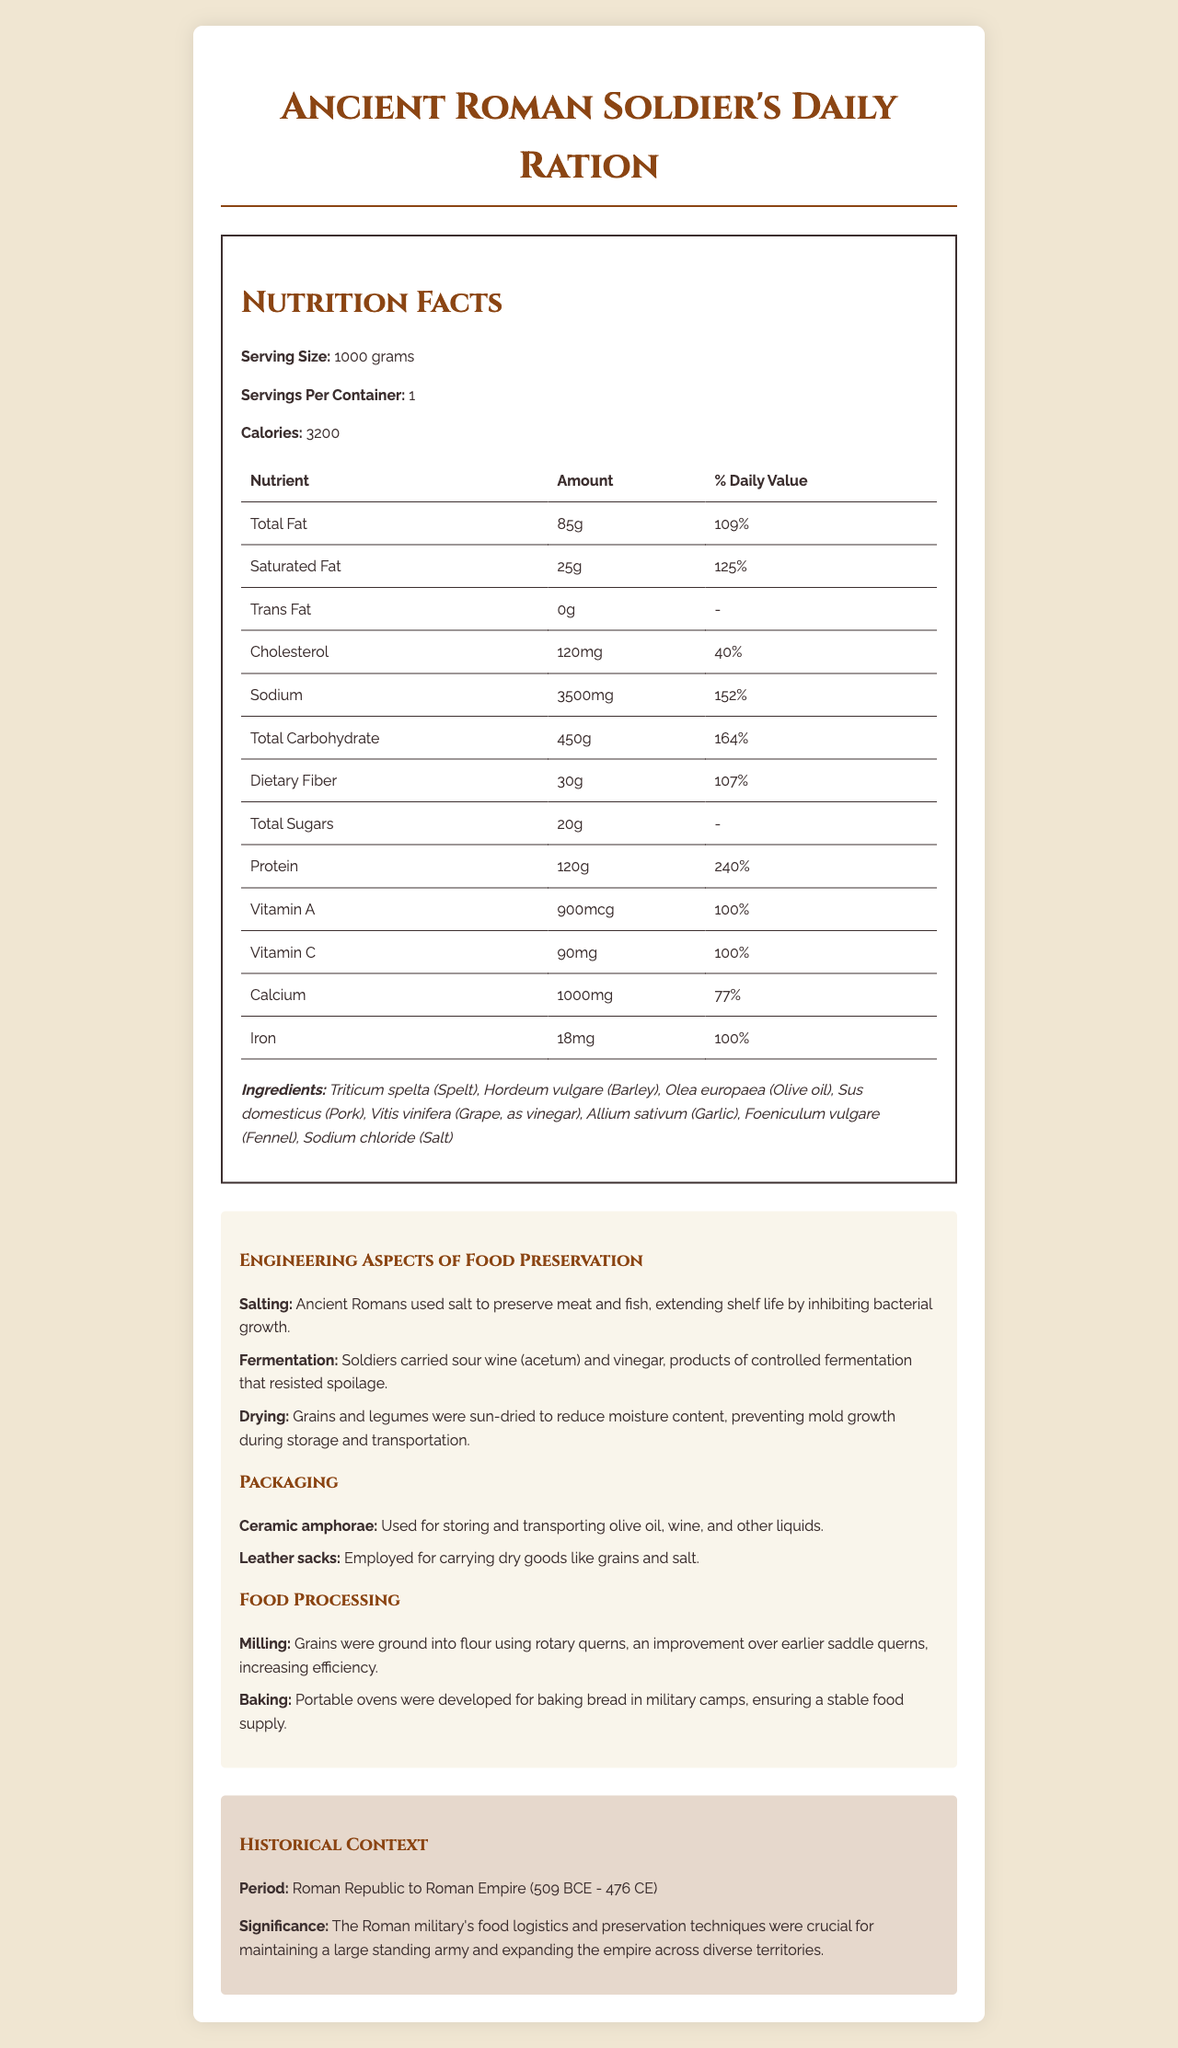what is the calorie count for a serving? The document specifies that the calorie count per serving is 3200 calories.
Answer: 3200 calories what are the main ingredients listed for the Ancient Roman Soldier's Daily Ration? The document lists these as the main ingredients under the ingredients section.
Answer: Triticum spelta (Spelt), Hordeum vulgare (Barley), Olea europaea (Olive oil), Sus domesticus (Pork), Vitis vinifera (Grape, as vinegar), Allium sativum (Garlic), Foeniculum vulgare (Fennel), Sodium chloride (Salt) how does milling improve food processing? The document mentions that milling grains into flour using rotary querns improves efficiency.
Answer: It increases efficiency by grinding grains into flour using rotary querns, which are an improvement over earlier saddle querns. what method was used by the Romans to preserve their meat and fish? The document states that salt was used by the Romans to preserve meat and fish.
Answer: Salting what is the historical significance of the food logistics and preservation techniques used by the Roman military? The document explains that these techniques were significant for maintaining the Roman military's strength and expansion.
Answer: They were crucial for maintaining a large standing army and expanding the empire across diverse territories. how much total fat is in one serving of the ration? The document states that the total fat content per serving is 85 grams.
Answer: 85 grams how much sodium is in a single serving? The document indicates that the sodium content per serving is 3500 mg.
Answer: 3500 mg what percentage of daily value does the protein in one serving provide? The document shows that the protein content per serving provides 240% of the daily value.
Answer: 240% what is the main method the Romans used to prevent spoilage in their sour wine? A. Salting B. Fermentation C. Drying D. Freezing The document states that fermentation was used to produce sour wine and vinegar, which resisted spoilage.
Answer: B. Fermentation what type of packaging was used for dry goods like grains and salt? A. Wooden barrels B. Ceramic amphorae C. Leather sacks D. Metal containers The document specifies that leather sacks were used for carrying dry goods like grains and salt.
Answer: C. Leather sacks are there any trans fats present in the Ancient Roman Soldier's Daily Ration? The document indicates that there are 0 grams of trans fats.
Answer: No summarize the main idea of the document. The document includes detailed nutritional information, lists key ingredients, and describes various engineering techniques used for food preservation, packaging, and processing by ancient Romans, emphasizing their importance in the historical context.
Answer: The document provides a comprehensive overview of the nutrition facts, ingredients, and engineering aspects of food preservation, packaging, and processing techniques used in the daily ration of an ancient Roman soldier. It highlights the historical context and significance of these practices in maintaining and expanding the Roman military. what tools or techniques did Romans use to bake bread in military camps? The document mentions that portable ovens were developed to bake bread in military camps, ensuring a stable food supply.
Answer: Portable ovens what is the percentage daily value of calcium provided by one serving of the ration? The document states that the calcium content per serving provides 77% of the daily value.
Answer: 77% how many grams of dietary fiber are in one serving? The document shows that the dietary fiber content per serving is 30 grams.
Answer: 30 grams which period does the historical context of the ration cover? The document specifies that the historical context covers the period from the Roman Republic to the Roman Empire, spanning 509 BCE to 476 CE.
Answer: Roman Republic to Roman Empire (509 BCE - 476 CE) can we determine the exact daily diet variety of an ancient Roman soldier from this document alone? While the document provides detailed information about the daily ration, it does not cover the variety of the entire daily diet of an ancient Roman soldier.
Answer: Cannot be determined 